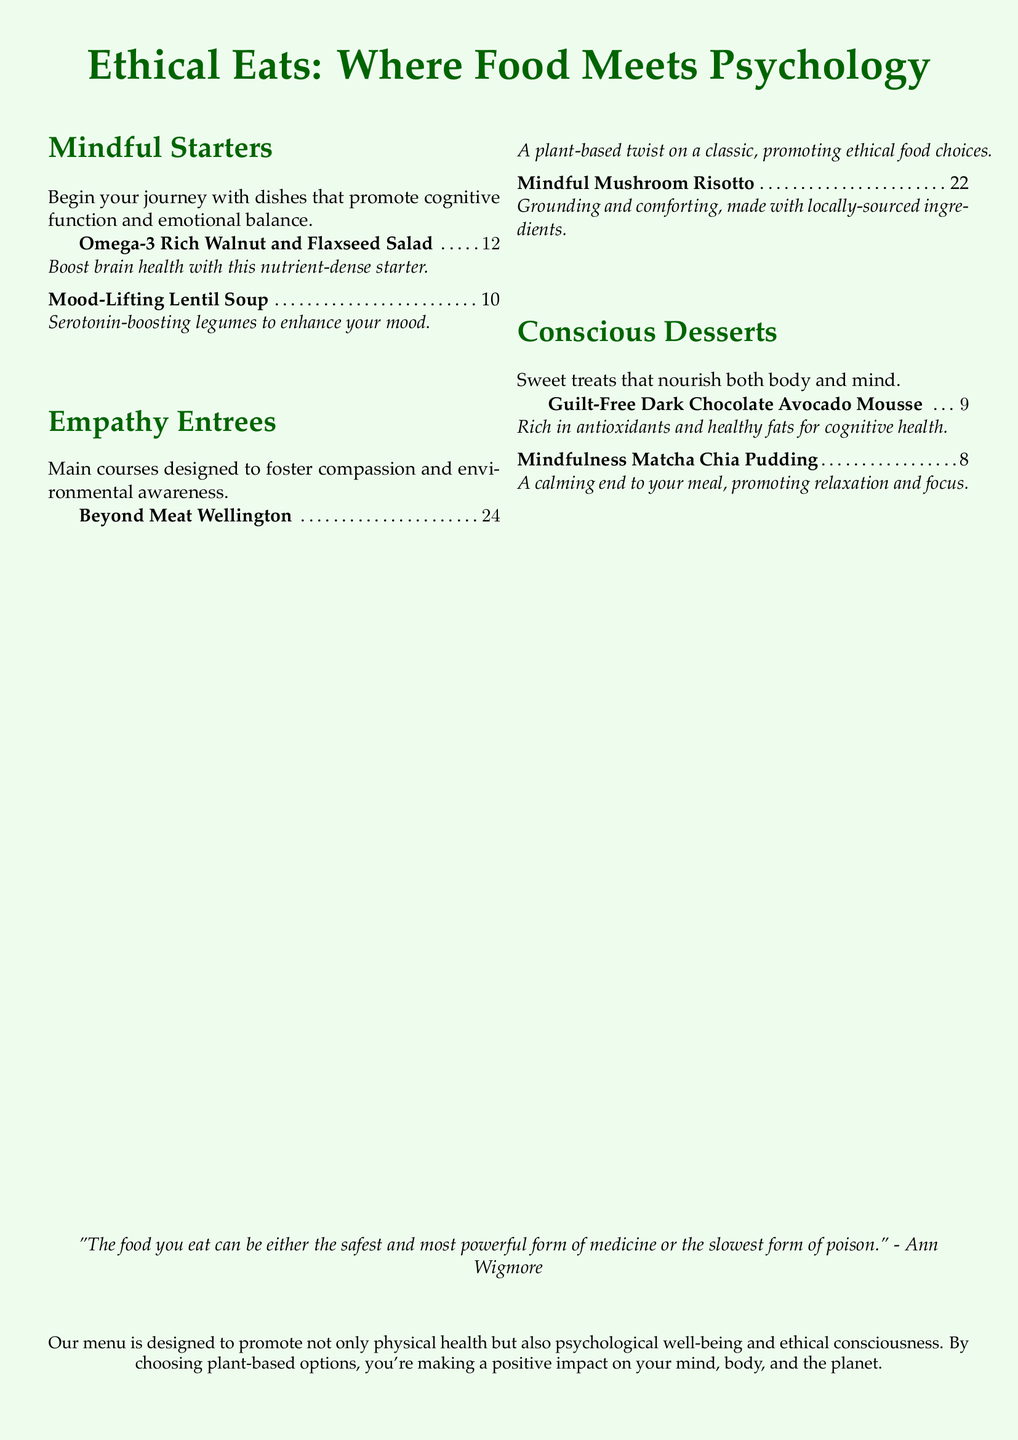What is the price of the Omega-3 Rich Walnut and Flaxseed Salad? The price of the Omega-3 Rich Walnut and Flaxseed Salad is listed next to the dish name.
Answer: $12 What ingredient is mentioned as boosting brain health in a starter? The dish mentions walnut and flaxseed as ingredients that promote brain health.
Answer: Walnut and Flaxseed How many desserts are listed on the menu? The dessert section includes two items, which can be counted directly from the document.
Answer: 2 What is the main focus of the restaurant menu? The document's introduction emphasizes promoting physical health, psychological well-being, and ethical consciousness through menu items.
Answer: Ethical consciousness Which dish is described as “grounding and comforting”? The document uses this description for one of the main courses, which can be identified in the menu section.
Answer: Mindful Mushroom Risotto What is the description of the Guilt-Free Dark Chocolate Avocado Mousse? The description is provided in the dessert section, highlighting its benefits for cognitive health.
Answer: Rich in antioxidants and healthy fats for cognitive health What is the primary psychological benefit mentioned for the Mood-Lifting Lentil Soup? This soup is stated to enhance mood, which relates directly to its ingredients.
Answer: Enhance your mood How does the menu categorize its offerings? The structure of the menu includes distinct sections that classify the dishes based on themes or benefits.
Answer: Mindful Starters, Empathy Entrees, Conscious Desserts 